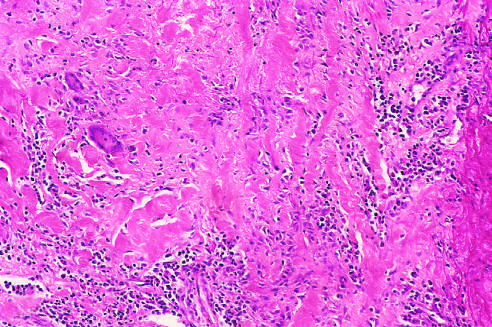what is histologic appearance in active takayasu aortitis illustrating destruction and fibrosis of the arterial media associated with?
Answer the question using a single word or phrase. Mononuclear infiltrates and giant cells 